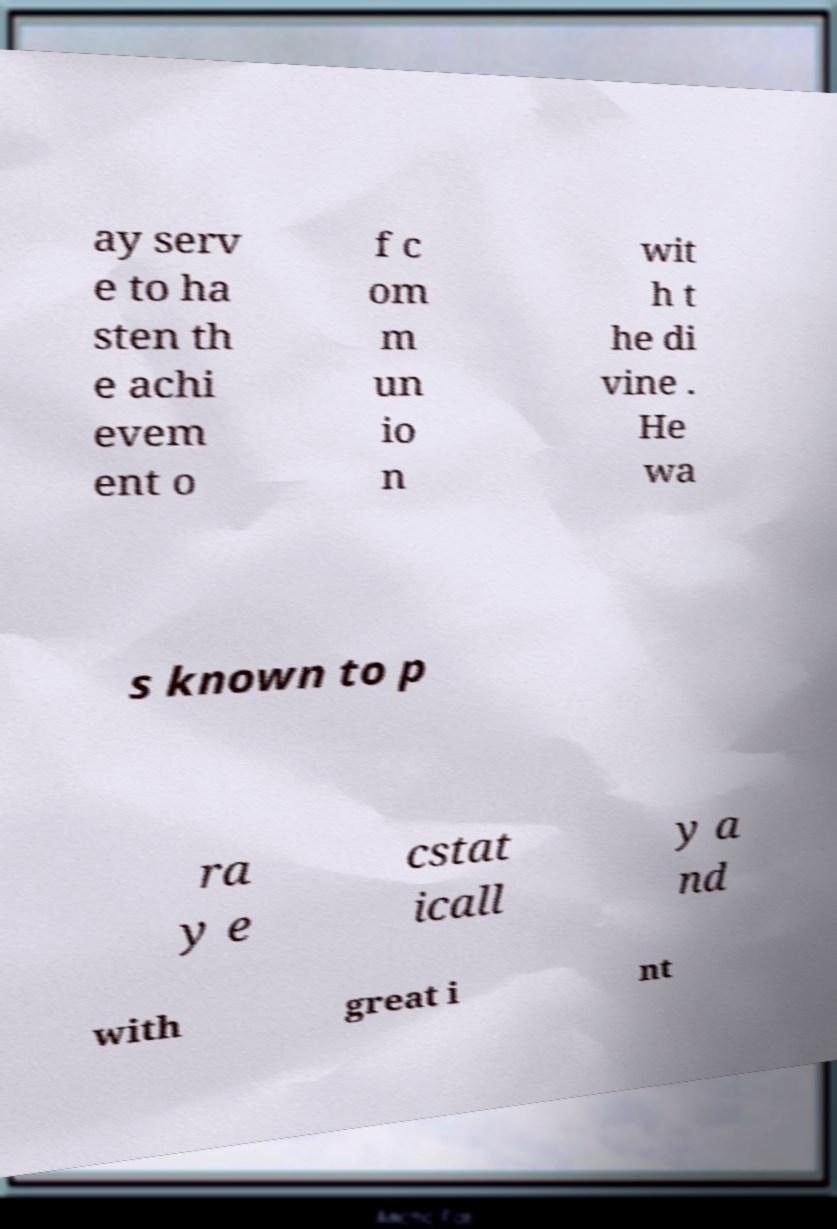Can you accurately transcribe the text from the provided image for me? ay serv e to ha sten th e achi evem ent o f c om m un io n wit h t he di vine . He wa s known to p ra y e cstat icall y a nd with great i nt 